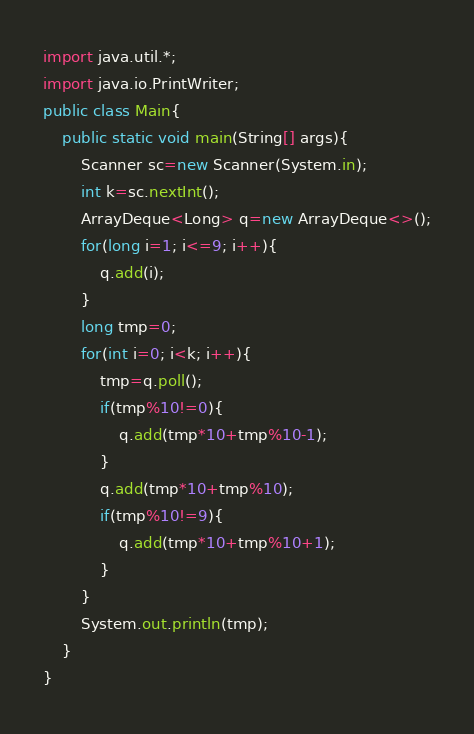Convert code to text. <code><loc_0><loc_0><loc_500><loc_500><_Java_>import java.util.*;
import java.io.PrintWriter;
public class Main{
	public static void main(String[] args){
		Scanner sc=new Scanner(System.in);
		int k=sc.nextInt();
		ArrayDeque<Long> q=new ArrayDeque<>();
		for(long i=1; i<=9; i++){
			q.add(i);
		}
		long tmp=0;
		for(int i=0; i<k; i++){
			tmp=q.poll();
			if(tmp%10!=0){
				q.add(tmp*10+tmp%10-1);
			} 
			q.add(tmp*10+tmp%10);
			if(tmp%10!=9){
				q.add(tmp*10+tmp%10+1);
			}
		}
		System.out.println(tmp);
	}
}
</code> 